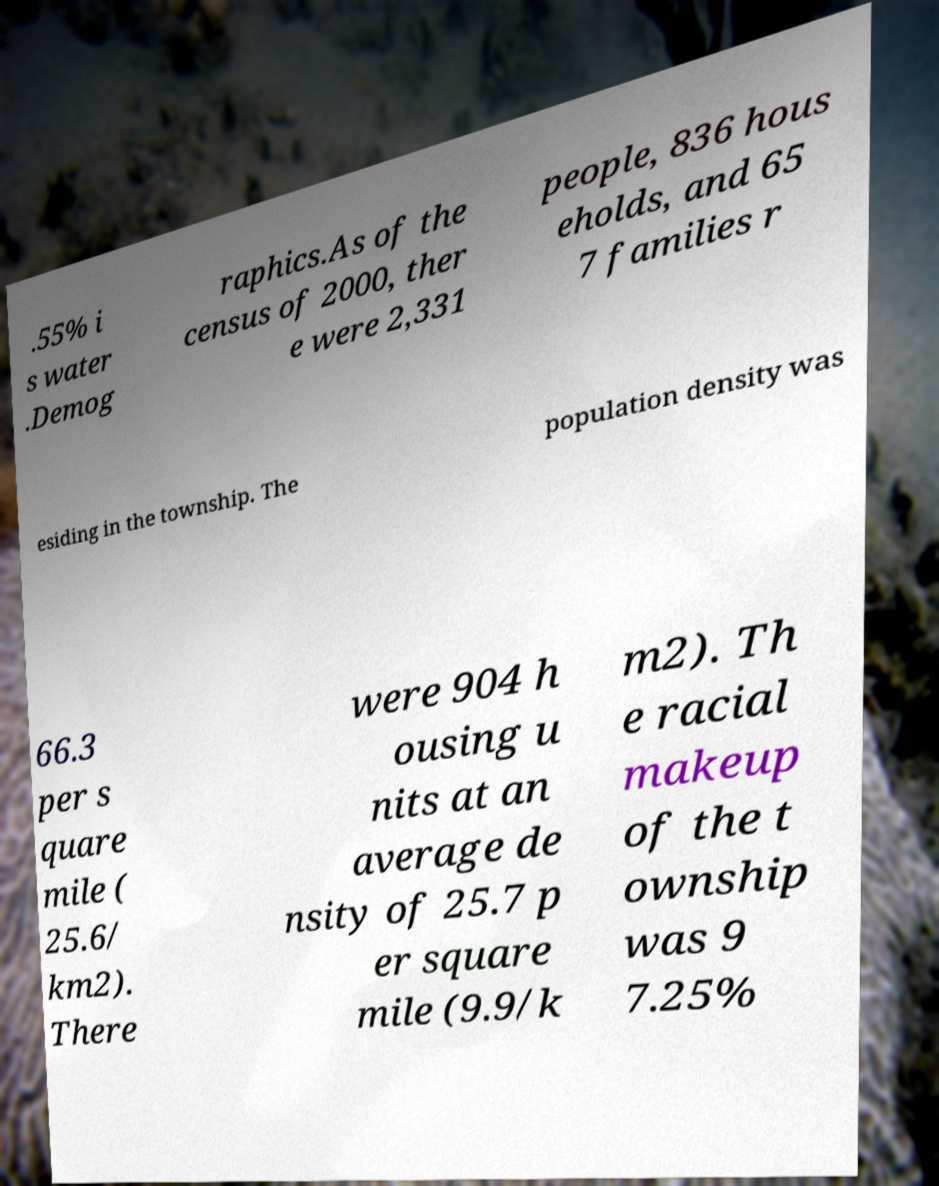Can you read and provide the text displayed in the image?This photo seems to have some interesting text. Can you extract and type it out for me? .55% i s water .Demog raphics.As of the census of 2000, ther e were 2,331 people, 836 hous eholds, and 65 7 families r esiding in the township. The population density was 66.3 per s quare mile ( 25.6/ km2). There were 904 h ousing u nits at an average de nsity of 25.7 p er square mile (9.9/k m2). Th e racial makeup of the t ownship was 9 7.25% 